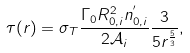Convert formula to latex. <formula><loc_0><loc_0><loc_500><loc_500>\tau ( r ) = \sigma _ { T } \frac { \Gamma _ { 0 } R _ { 0 , i } ^ { 2 } n _ { 0 , i } ^ { ^ { \prime } } } { 2 \mathcal { A } _ { i } } \frac { 3 } { 5 r ^ { \frac { 5 } { 3 } } } ,</formula> 